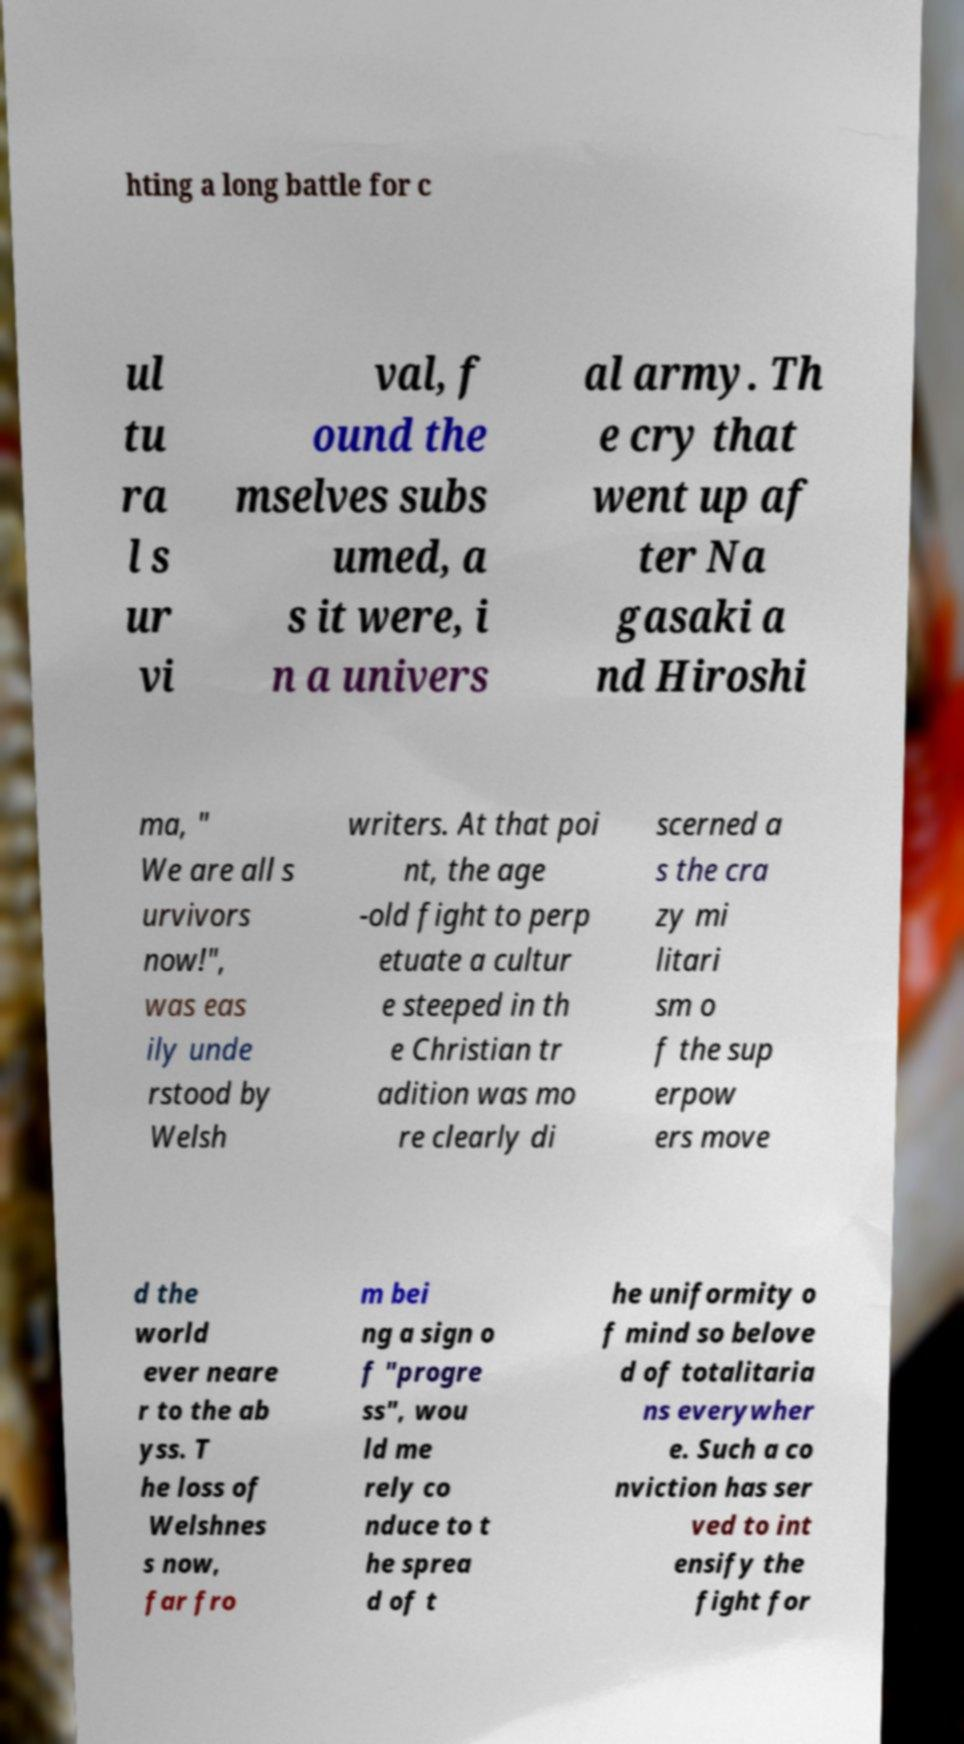There's text embedded in this image that I need extracted. Can you transcribe it verbatim? hting a long battle for c ul tu ra l s ur vi val, f ound the mselves subs umed, a s it were, i n a univers al army. Th e cry that went up af ter Na gasaki a nd Hiroshi ma, " We are all s urvivors now!", was eas ily unde rstood by Welsh writers. At that poi nt, the age -old fight to perp etuate a cultur e steeped in th e Christian tr adition was mo re clearly di scerned a s the cra zy mi litari sm o f the sup erpow ers move d the world ever neare r to the ab yss. T he loss of Welshnes s now, far fro m bei ng a sign o f "progre ss", wou ld me rely co nduce to t he sprea d of t he uniformity o f mind so belove d of totalitaria ns everywher e. Such a co nviction has ser ved to int ensify the fight for 